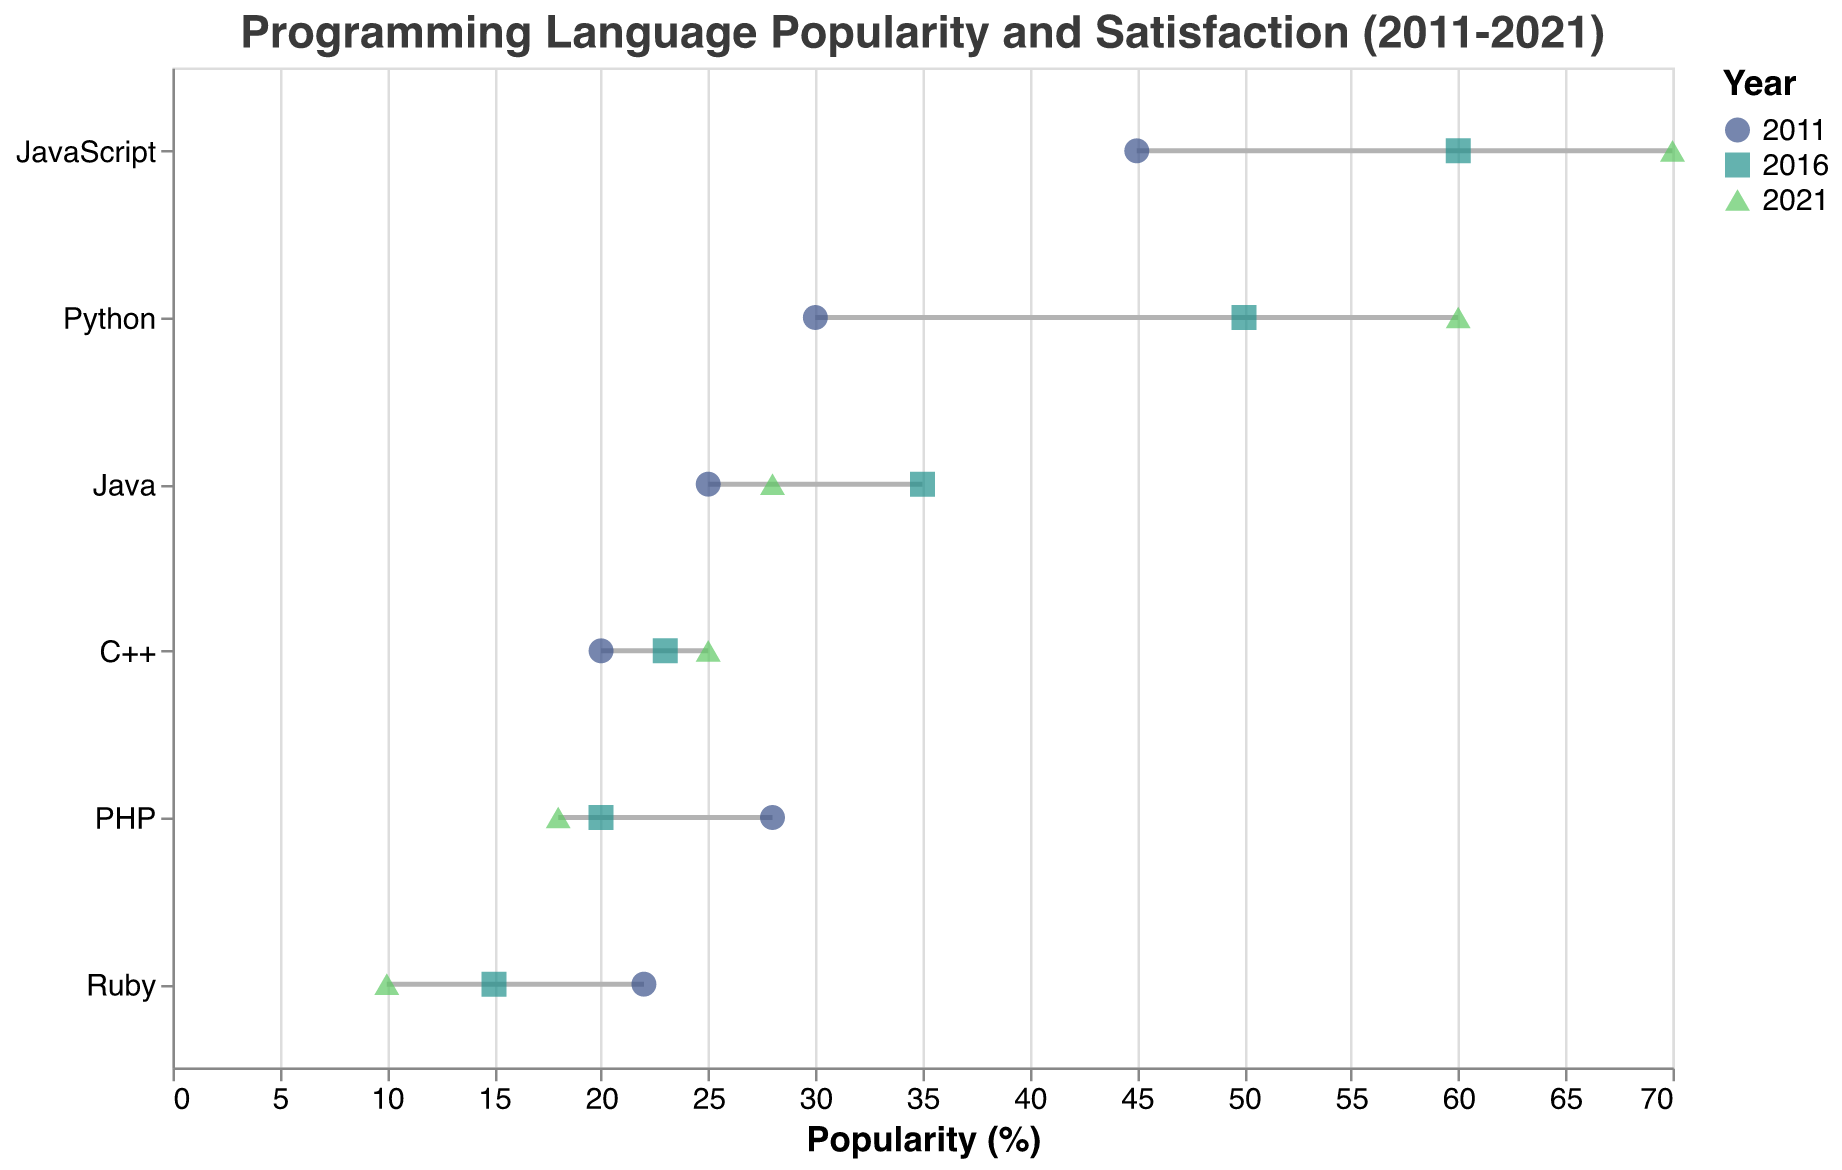What is the title of the plot? The title of the plot is positioned at the top center of the figure, typically in a larger font size.
Answer: Programming Language Popularity and Satisfaction (2011-2021) Which programming language had the highest satisfaction in 2021? Look at the satisfaction values for 2021 and identify the maximum value. The maximum satisfaction in 2021 is for Python with a satisfaction of 88.
Answer: Python How did JavaScript's popularity change from 2011 to 2021? To determine the change, look at JavaScript's popularity in 2011 (45) and its popularity in 2021 (70). Calculate the difference: 70 - 45.
Answer: Increased by 25 Which language showed the largest decrease in popularity from 2011 to 2021? Calculate the decrease in popularity for each language. Ruby had a popularity of 22 in 2011 and 10 in 2021, so the decrease is 22 - 10 = 12, which is the largest decrease among the languages listed.
Answer: Ruby Which year had the highest average satisfaction for all languages? Calculate the average satisfaction for each year: 
2011: (80 + 85 + 75 + 70 + 72 + 65) / 6 = 74.5
2016: (75 + 85 + 70 + 65 + 60 + 55) / 6 = 68.3
2021: (78 + 88 + 68 + 66 + 58 + 50) / 6 = 68.0
The highest average satisfaction is in 2011.
Answer: 2011 Which programming languages saw an increase in both popularity and satisfaction from 2011 to 2021? Compare popularity and satisfaction values for 2011 and 2021. JavaScript and Python both saw increases in both metrics.
Answer: JavaScript, Python Among the listed programming languages, which one had the lowest satisfaction in any year, and what was that value? By inspecting the satisfaction values across all years, PHP had the lowest satisfaction in 2021 with a value of 50.
Answer: PHP, 50 How did the satisfaction for Java change from 2011 to 2021? Look at Java's satisfaction values in 2011 (75) and 2021 (68). Calculate the difference: 75 - 68.
Answer: Decreased by 7 Compare the popularity of C++ across the three years shown. Did it increase, decrease, or remain the same? Look at C++ popularity values for 2011 (20), 2016 (23), and 2021 (25). From 2011 to 2021, the popularity increased.
Answer: Increased What is the popularity trend for Ruby from 2011 to 2021? Review Ruby's popularity values in 2011 (22), 2016 (15), and 2021 (10). Observe the decreasing trend.
Answer: Decreased 